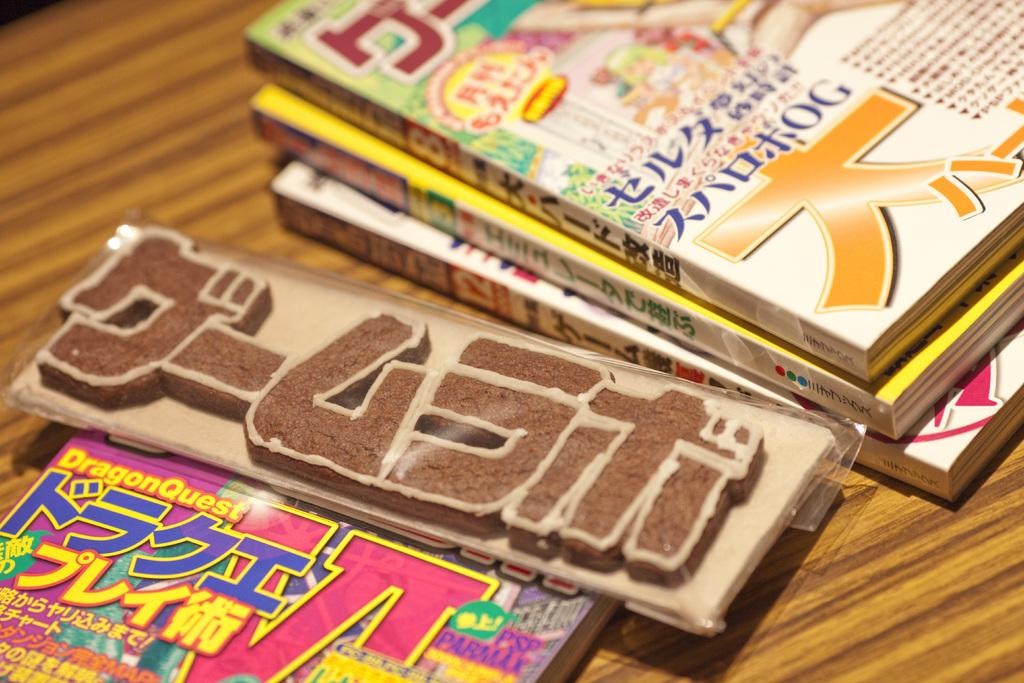<image>
Render a clear and concise summary of the photo. Some magazines, one of which has the words DragonQuest at the top. 